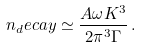Convert formula to latex. <formula><loc_0><loc_0><loc_500><loc_500>n _ { d } e c a y \simeq \frac { A \omega K ^ { 3 } } { 2 \pi ^ { 3 } \Gamma } \, .</formula> 